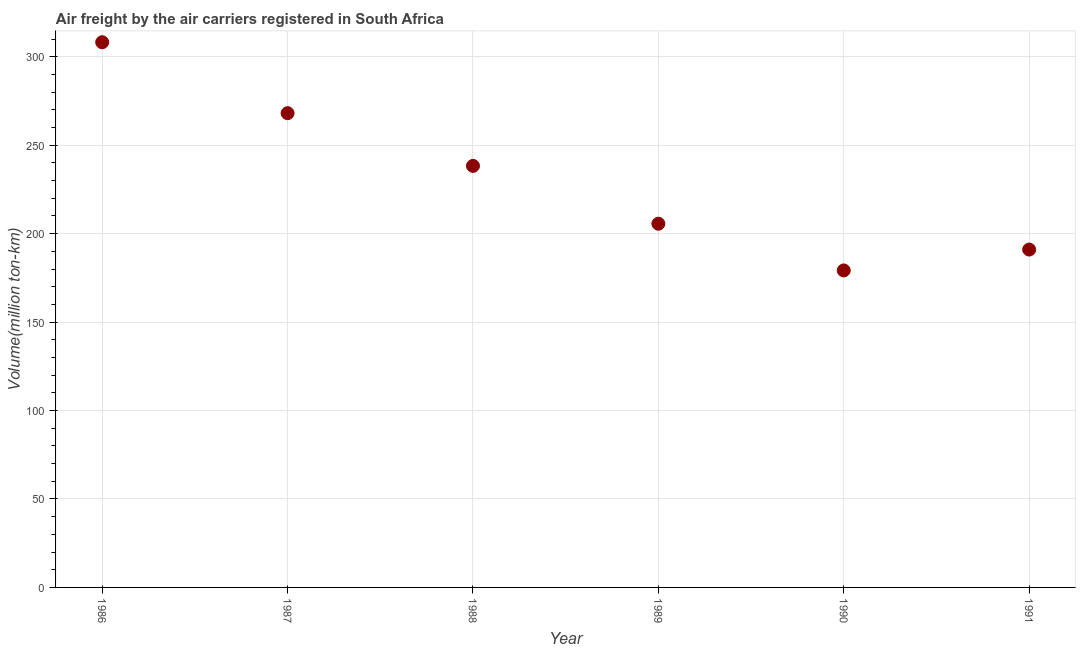What is the air freight in 1988?
Make the answer very short. 238.3. Across all years, what is the maximum air freight?
Give a very brief answer. 308.2. Across all years, what is the minimum air freight?
Ensure brevity in your answer.  179.2. In which year was the air freight maximum?
Provide a succinct answer. 1986. In which year was the air freight minimum?
Make the answer very short. 1990. What is the sum of the air freight?
Your answer should be very brief. 1390.4. What is the difference between the air freight in 1989 and 1990?
Ensure brevity in your answer.  26.4. What is the average air freight per year?
Provide a short and direct response. 231.73. What is the median air freight?
Offer a terse response. 221.95. In how many years, is the air freight greater than 220 million ton-km?
Provide a succinct answer. 3. What is the ratio of the air freight in 1989 to that in 1990?
Offer a terse response. 1.15. Is the air freight in 1989 less than that in 1990?
Your response must be concise. No. Is the difference between the air freight in 1988 and 1990 greater than the difference between any two years?
Offer a very short reply. No. What is the difference between the highest and the second highest air freight?
Provide a short and direct response. 40.1. What is the difference between the highest and the lowest air freight?
Keep it short and to the point. 129. How many years are there in the graph?
Provide a short and direct response. 6. What is the difference between two consecutive major ticks on the Y-axis?
Make the answer very short. 50. Does the graph contain any zero values?
Your response must be concise. No. Does the graph contain grids?
Give a very brief answer. Yes. What is the title of the graph?
Keep it short and to the point. Air freight by the air carriers registered in South Africa. What is the label or title of the Y-axis?
Ensure brevity in your answer.  Volume(million ton-km). What is the Volume(million ton-km) in 1986?
Offer a terse response. 308.2. What is the Volume(million ton-km) in 1987?
Offer a terse response. 268.1. What is the Volume(million ton-km) in 1988?
Your response must be concise. 238.3. What is the Volume(million ton-km) in 1989?
Your answer should be very brief. 205.6. What is the Volume(million ton-km) in 1990?
Make the answer very short. 179.2. What is the Volume(million ton-km) in 1991?
Your answer should be compact. 191. What is the difference between the Volume(million ton-km) in 1986 and 1987?
Make the answer very short. 40.1. What is the difference between the Volume(million ton-km) in 1986 and 1988?
Provide a succinct answer. 69.9. What is the difference between the Volume(million ton-km) in 1986 and 1989?
Offer a very short reply. 102.6. What is the difference between the Volume(million ton-km) in 1986 and 1990?
Offer a terse response. 129. What is the difference between the Volume(million ton-km) in 1986 and 1991?
Make the answer very short. 117.2. What is the difference between the Volume(million ton-km) in 1987 and 1988?
Your response must be concise. 29.8. What is the difference between the Volume(million ton-km) in 1987 and 1989?
Provide a succinct answer. 62.5. What is the difference between the Volume(million ton-km) in 1987 and 1990?
Ensure brevity in your answer.  88.9. What is the difference between the Volume(million ton-km) in 1987 and 1991?
Offer a very short reply. 77.1. What is the difference between the Volume(million ton-km) in 1988 and 1989?
Your answer should be compact. 32.7. What is the difference between the Volume(million ton-km) in 1988 and 1990?
Make the answer very short. 59.1. What is the difference between the Volume(million ton-km) in 1988 and 1991?
Your response must be concise. 47.3. What is the difference between the Volume(million ton-km) in 1989 and 1990?
Your answer should be very brief. 26.4. What is the difference between the Volume(million ton-km) in 1989 and 1991?
Your answer should be very brief. 14.6. What is the difference between the Volume(million ton-km) in 1990 and 1991?
Ensure brevity in your answer.  -11.8. What is the ratio of the Volume(million ton-km) in 1986 to that in 1987?
Your response must be concise. 1.15. What is the ratio of the Volume(million ton-km) in 1986 to that in 1988?
Provide a succinct answer. 1.29. What is the ratio of the Volume(million ton-km) in 1986 to that in 1989?
Provide a short and direct response. 1.5. What is the ratio of the Volume(million ton-km) in 1986 to that in 1990?
Make the answer very short. 1.72. What is the ratio of the Volume(million ton-km) in 1986 to that in 1991?
Your answer should be compact. 1.61. What is the ratio of the Volume(million ton-km) in 1987 to that in 1988?
Your answer should be compact. 1.12. What is the ratio of the Volume(million ton-km) in 1987 to that in 1989?
Your response must be concise. 1.3. What is the ratio of the Volume(million ton-km) in 1987 to that in 1990?
Ensure brevity in your answer.  1.5. What is the ratio of the Volume(million ton-km) in 1987 to that in 1991?
Keep it short and to the point. 1.4. What is the ratio of the Volume(million ton-km) in 1988 to that in 1989?
Ensure brevity in your answer.  1.16. What is the ratio of the Volume(million ton-km) in 1988 to that in 1990?
Provide a short and direct response. 1.33. What is the ratio of the Volume(million ton-km) in 1988 to that in 1991?
Offer a very short reply. 1.25. What is the ratio of the Volume(million ton-km) in 1989 to that in 1990?
Ensure brevity in your answer.  1.15. What is the ratio of the Volume(million ton-km) in 1989 to that in 1991?
Offer a very short reply. 1.08. What is the ratio of the Volume(million ton-km) in 1990 to that in 1991?
Keep it short and to the point. 0.94. 